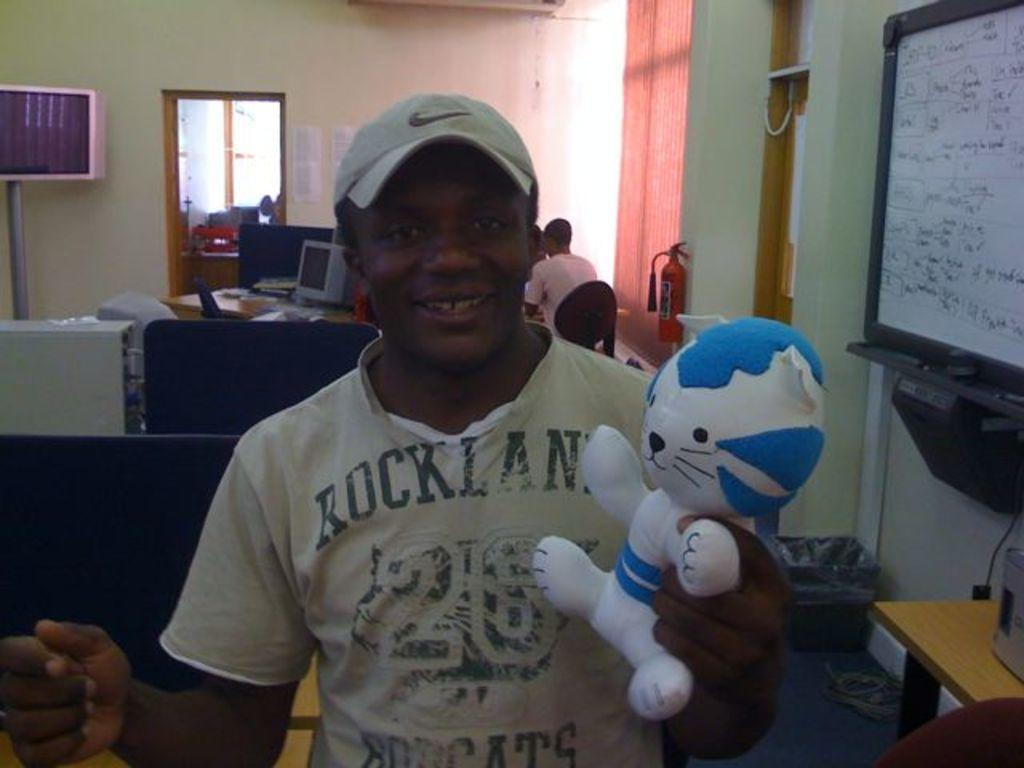What is the person in the image wearing on their head? There is a person wearing a hat in the image. What is the person with the hat holding? The person is holding a toy. Can you describe the position of the second person in the image? There is another person sitting behind the person with the hat. What is located beside the person with the hat? There is a whiteboard beside the person with the hat. What can be seen on the whiteboard? There is writing on the whiteboard. What type of corn is being grown on the person's face in the image? There is no corn or person's face present in the image; it features a person wearing a hat and holding a toy, with another person sitting behind them. 